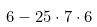<formula> <loc_0><loc_0><loc_500><loc_500>6 - 2 5 \cdot 7 \cdot 6</formula> 